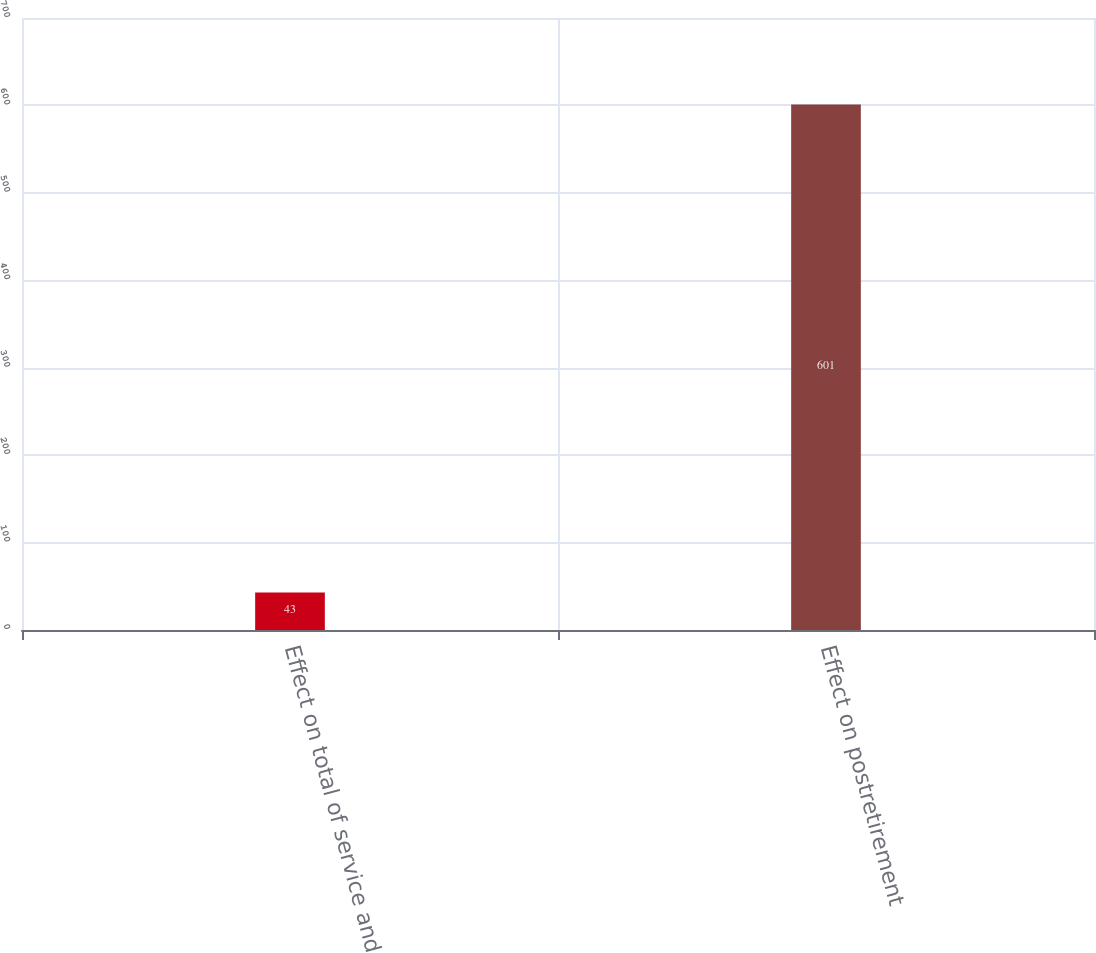Convert chart. <chart><loc_0><loc_0><loc_500><loc_500><bar_chart><fcel>Effect on total of service and<fcel>Effect on postretirement<nl><fcel>43<fcel>601<nl></chart> 